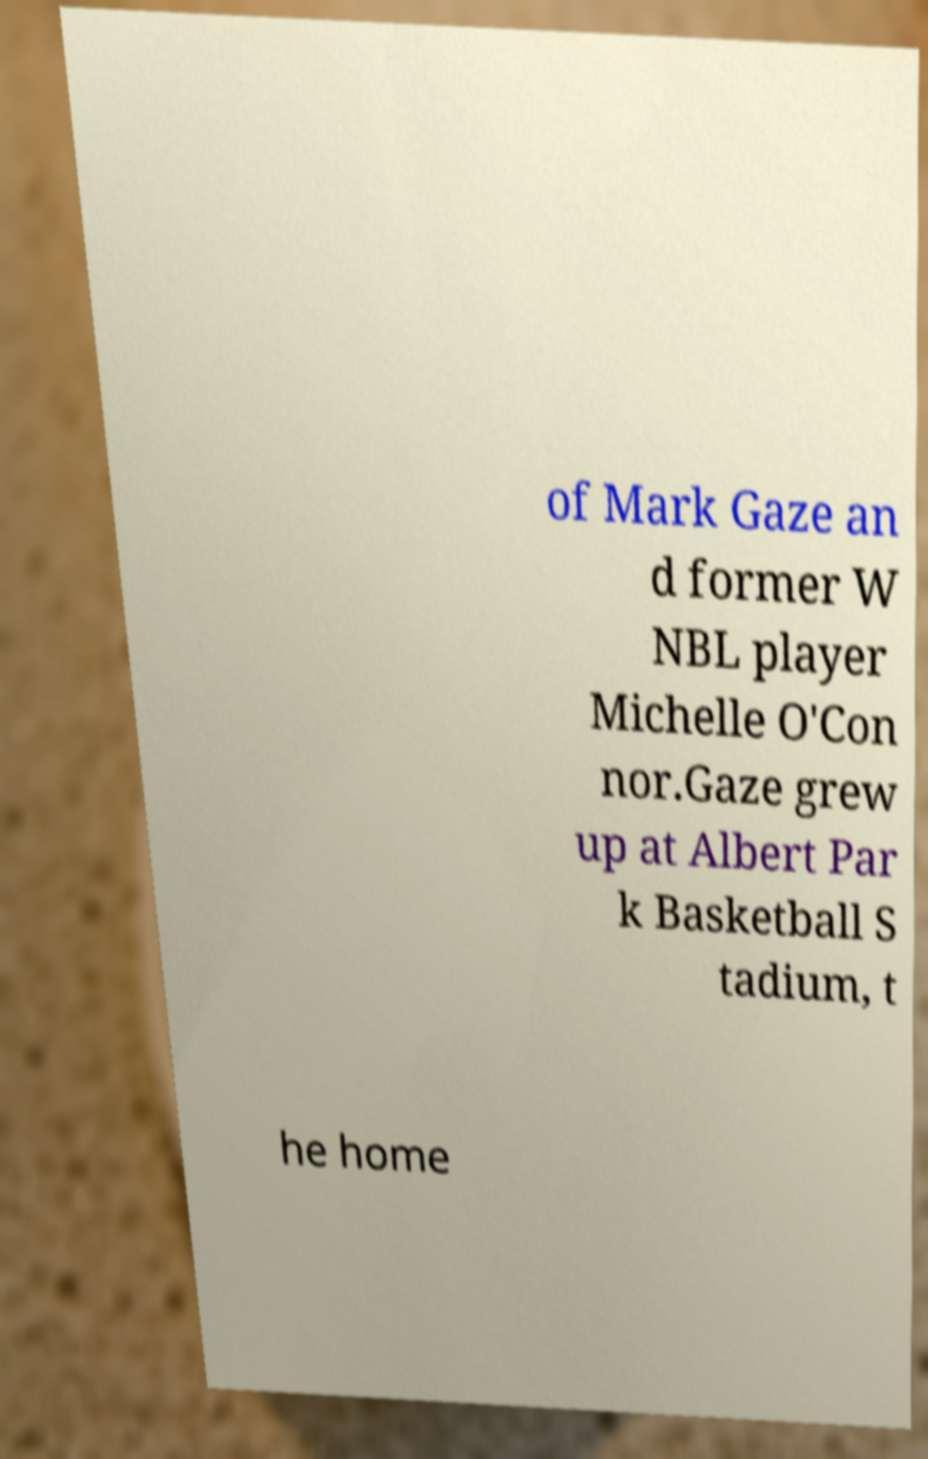Please read and relay the text visible in this image. What does it say? of Mark Gaze an d former W NBL player Michelle O'Con nor.Gaze grew up at Albert Par k Basketball S tadium, t he home 